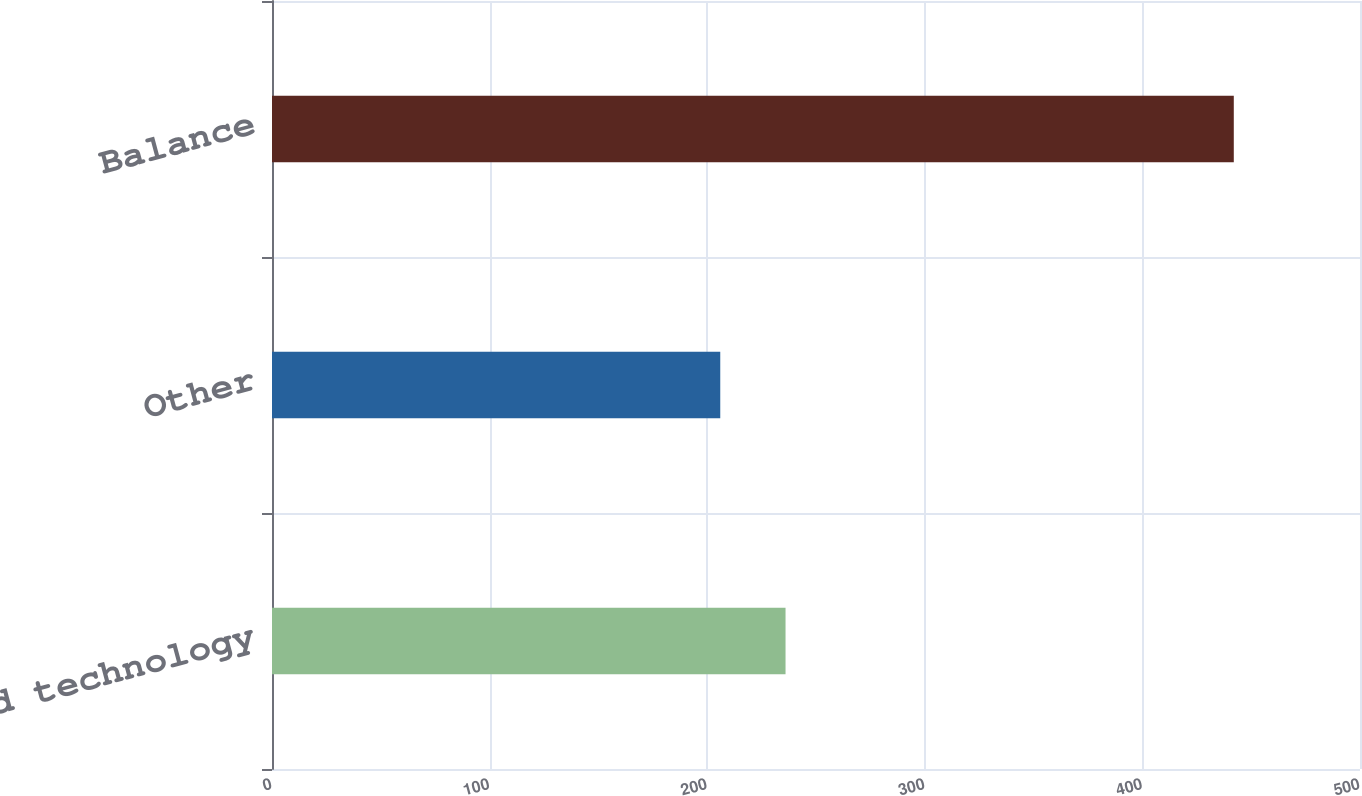Convert chart. <chart><loc_0><loc_0><loc_500><loc_500><bar_chart><fcel>Acquired technology<fcel>Other<fcel>Balance<nl><fcel>236<fcel>206<fcel>442<nl></chart> 